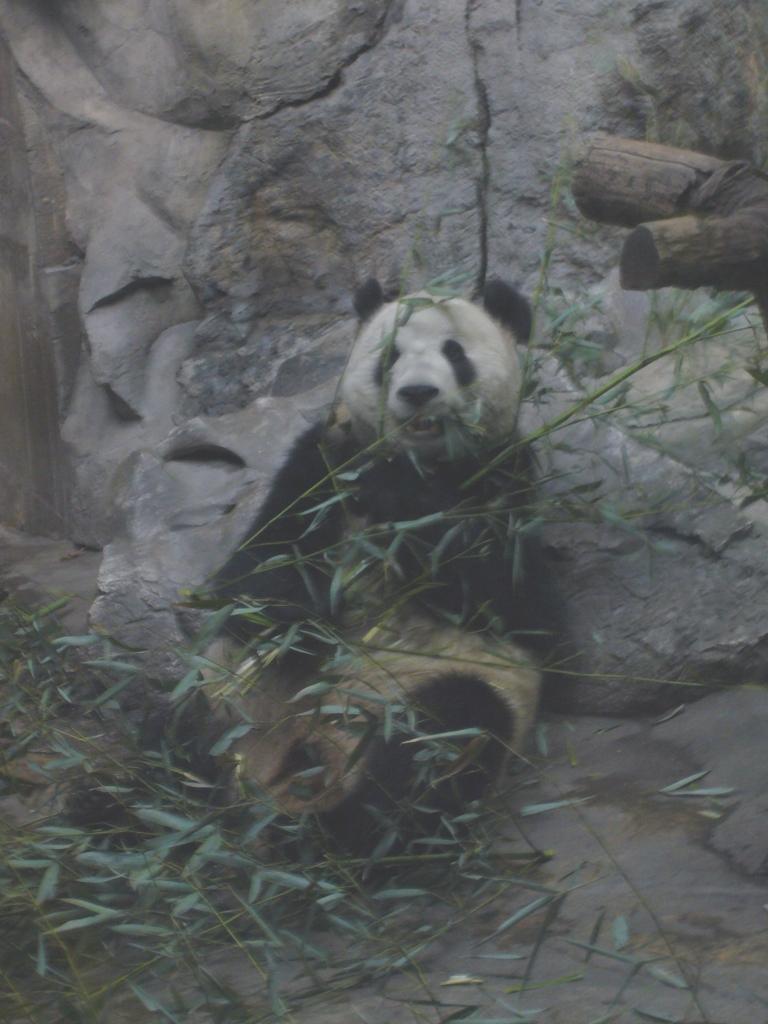In one or two sentences, can you explain what this image depicts? In this image we can see a panda, plants. In the background of the image there is a rock. There is a tree trunk to the right side of the image. 